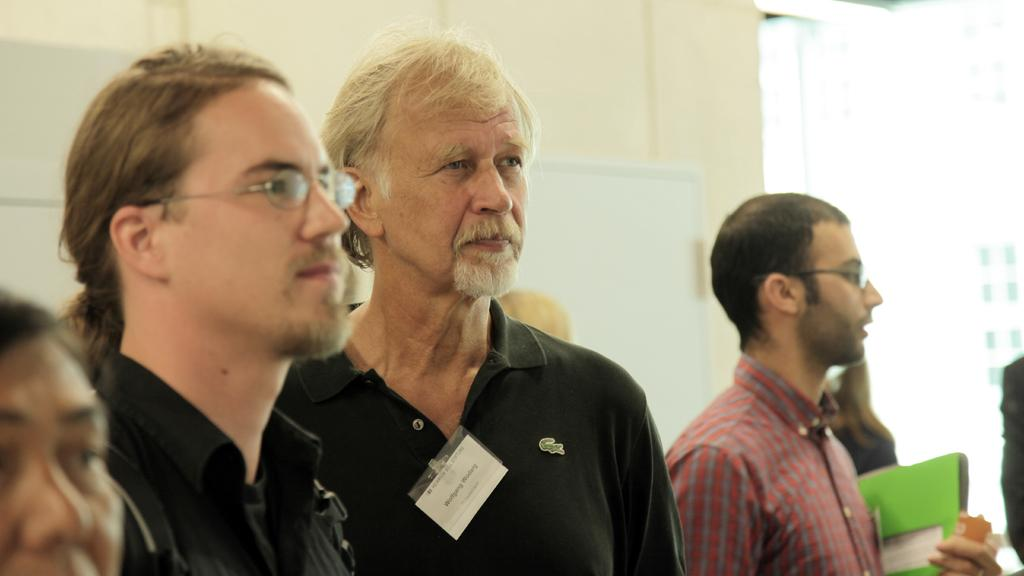How many people are in the image? There are people in the image, but the exact number is not specified. What is visible in the background of the image? There is a wall and a board in the background of the image. What type of grip can be seen on the people's hands in the image? There is no specific grip visible on the people's hands in the image. What type of society is depicted in the image? The image does not depict any specific society; it only shows people and a background. 